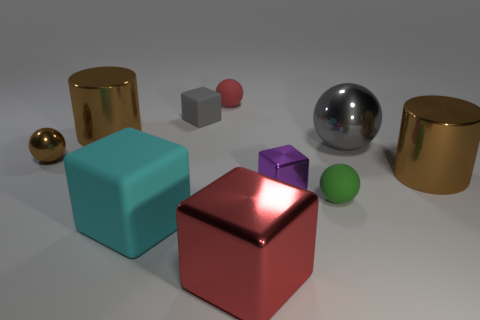What number of big brown cylinders are in front of the tiny brown metallic thing?
Your response must be concise. 1. What number of objects are either tiny blue rubber balls or red matte balls left of the green rubber object?
Keep it short and to the point. 1. There is a small block that is to the right of the red block; is there a small brown sphere that is in front of it?
Your answer should be compact. No. There is a tiny matte thing that is on the right side of the red ball; what color is it?
Your answer should be compact. Green. Are there the same number of brown shiny cylinders behind the small brown object and gray rubber blocks?
Make the answer very short. Yes. The rubber thing that is both in front of the tiny matte block and on the left side of the large red object has what shape?
Offer a terse response. Cube. What color is the other small rubber thing that is the same shape as the small purple thing?
Give a very brief answer. Gray. Are there any other things that are the same color as the big shiny cube?
Offer a terse response. Yes. What is the shape of the gray thing that is to the right of the red thing behind the large cylinder right of the large gray metal thing?
Your response must be concise. Sphere. Does the gray thing to the left of the tiny red rubber object have the same size as the gray object in front of the gray block?
Your response must be concise. No. 